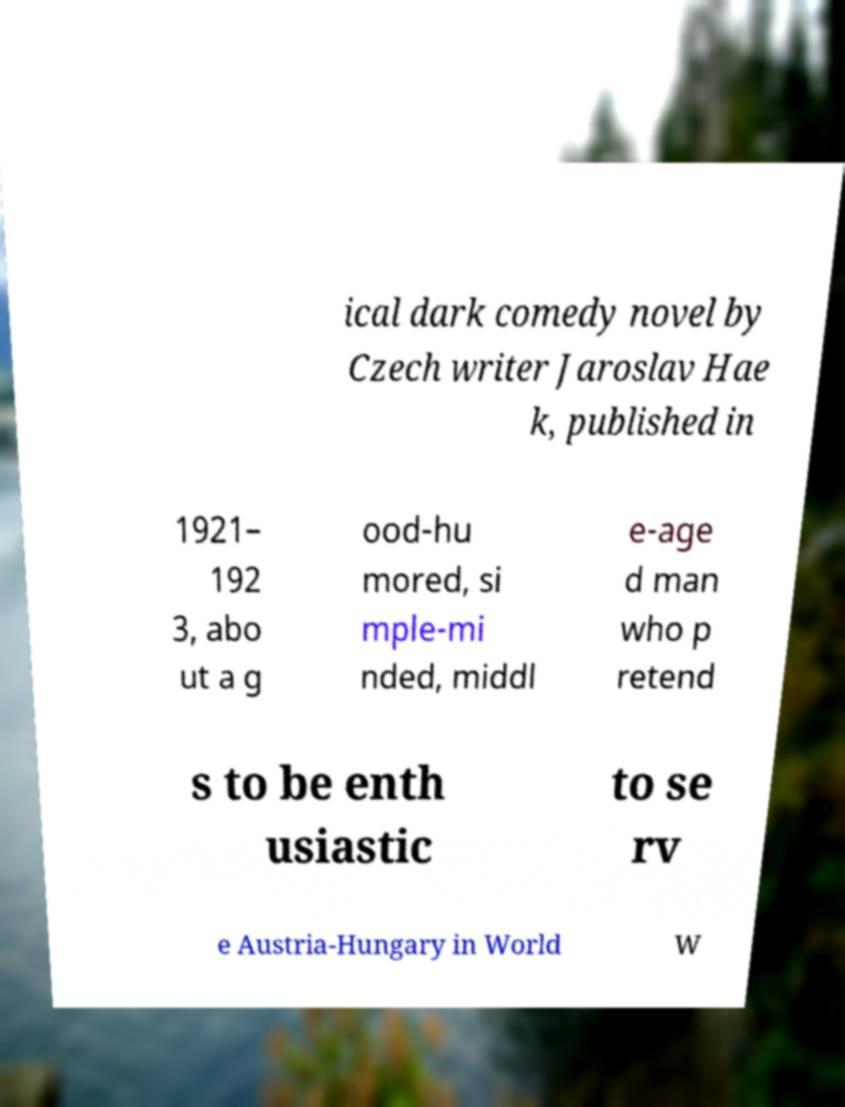What messages or text are displayed in this image? I need them in a readable, typed format. ical dark comedy novel by Czech writer Jaroslav Hae k, published in 1921– 192 3, abo ut a g ood-hu mored, si mple-mi nded, middl e-age d man who p retend s to be enth usiastic to se rv e Austria-Hungary in World W 